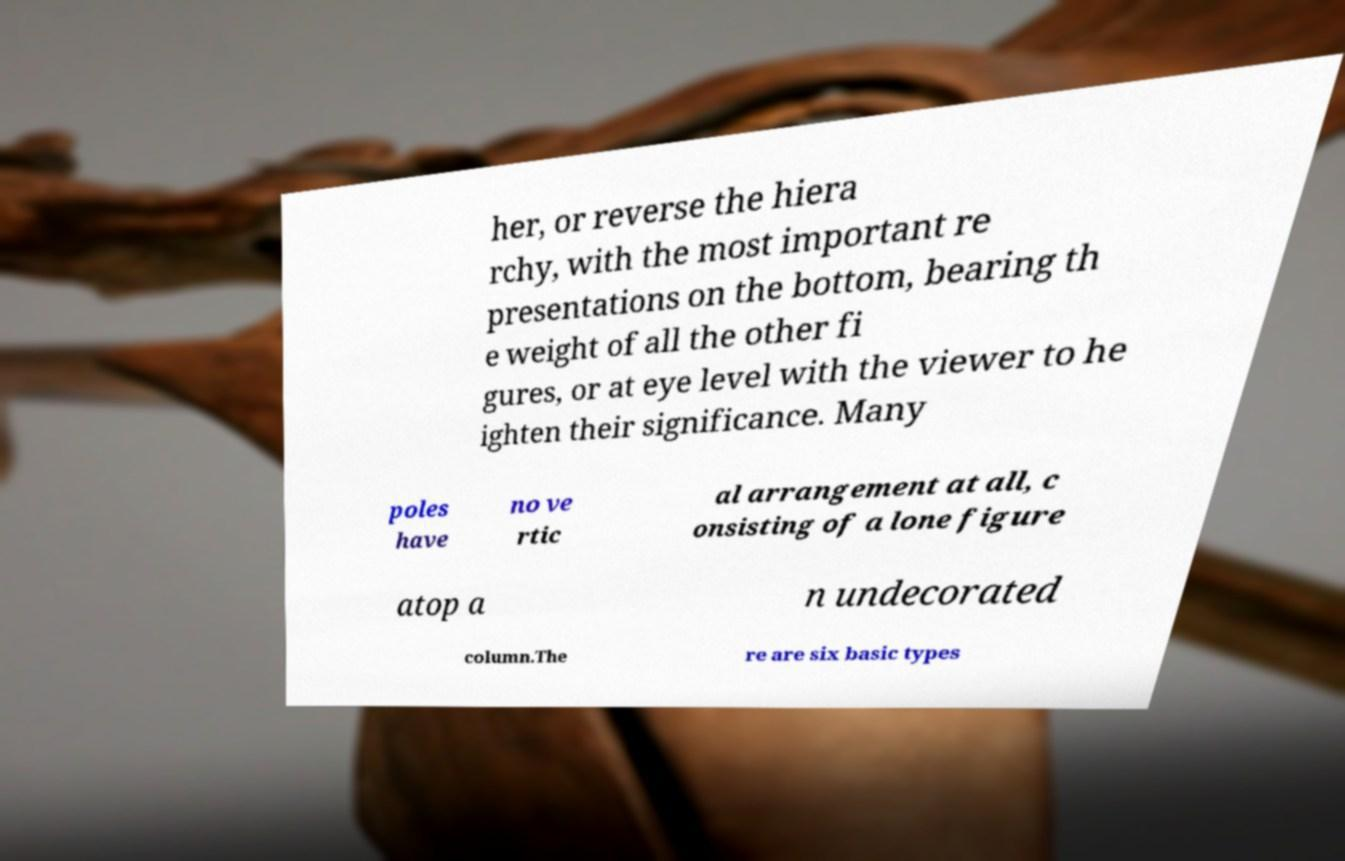For documentation purposes, I need the text within this image transcribed. Could you provide that? her, or reverse the hiera rchy, with the most important re presentations on the bottom, bearing th e weight of all the other fi gures, or at eye level with the viewer to he ighten their significance. Many poles have no ve rtic al arrangement at all, c onsisting of a lone figure atop a n undecorated column.The re are six basic types 